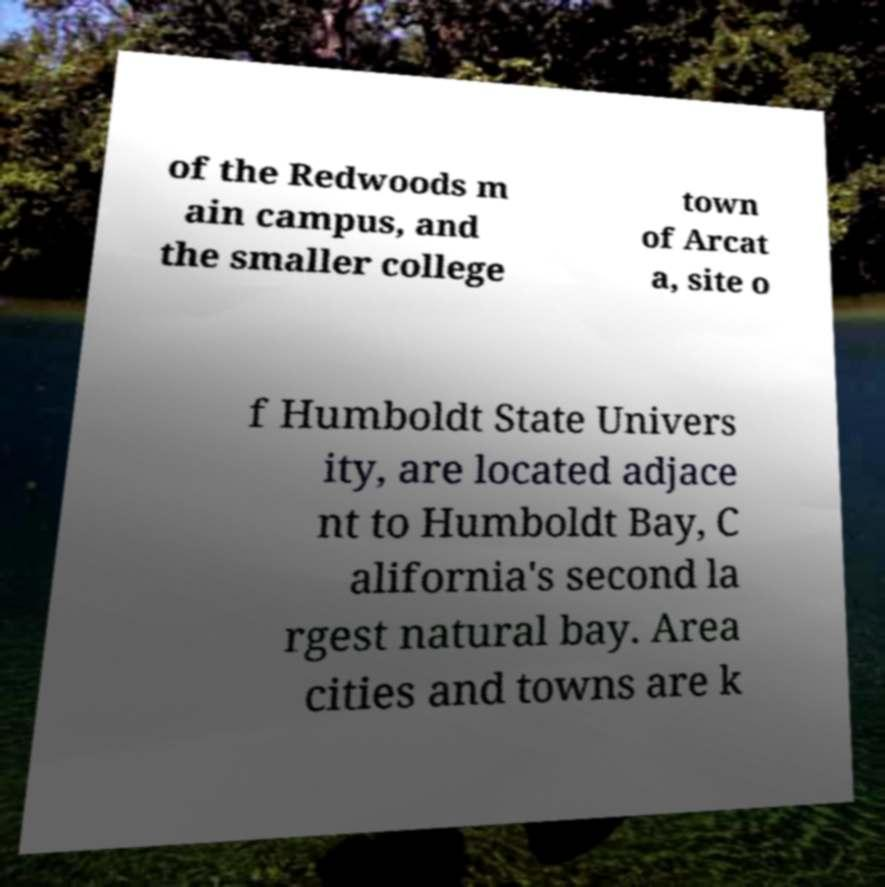Can you accurately transcribe the text from the provided image for me? of the Redwoods m ain campus, and the smaller college town of Arcat a, site o f Humboldt State Univers ity, are located adjace nt to Humboldt Bay, C alifornia's second la rgest natural bay. Area cities and towns are k 